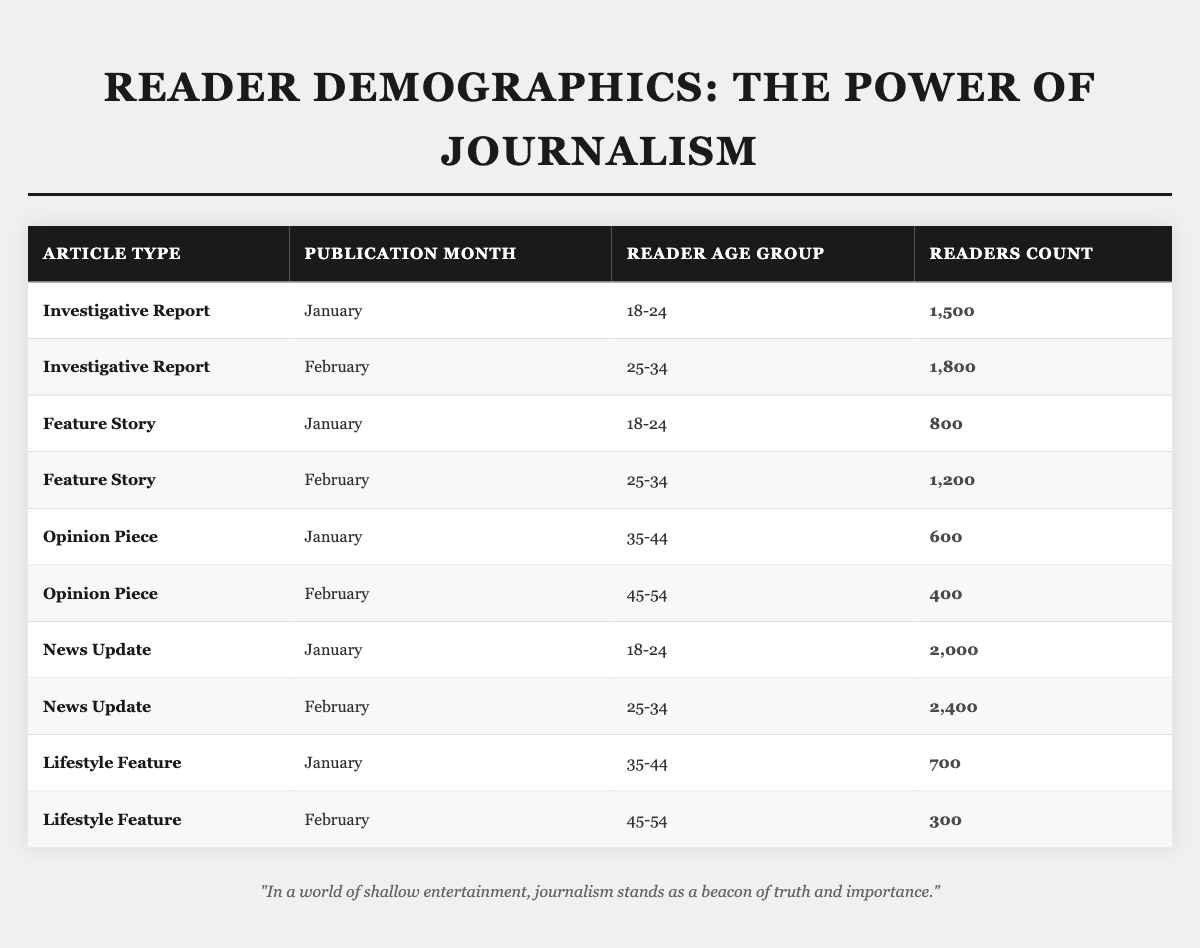What was the readers count for the "News Update" in January for the age group 18-24? Looking at the table, the "News Update" article type for January lists the readers count of 2,000 in the age group 18-24.
Answer: 2,000 Which article type had the highest readers count in February? In February, the "News Update" article type shows the highest readers count, which is 2,400, compared to other article types.
Answer: News Update How many readers aged 35-44 read "Opinion Piece" and "Lifestyle Feature" in January combined? For the "Opinion Piece," there were 600 readers aged 35-44 in January, and for the "Lifestyle Feature," there were 700 readers. Adding these together gives 600 + 700 = 1,300.
Answer: 1,300 Is there an article type that had no readers in any age group in February? After reviewing all the article types in February, it is clear that every article type has readers in the table, meaning there is no article type with zero readers for that month.
Answer: No What is the average readers count for the "Feature Story" article type across both months? The "Feature Story" had 800 readers in January and 1,200 readers in February. Adding these gives 800 + 1,200 = 2,000. Since there are 2 months, the average is 2,000 / 2 = 1,000.
Answer: 1,000 